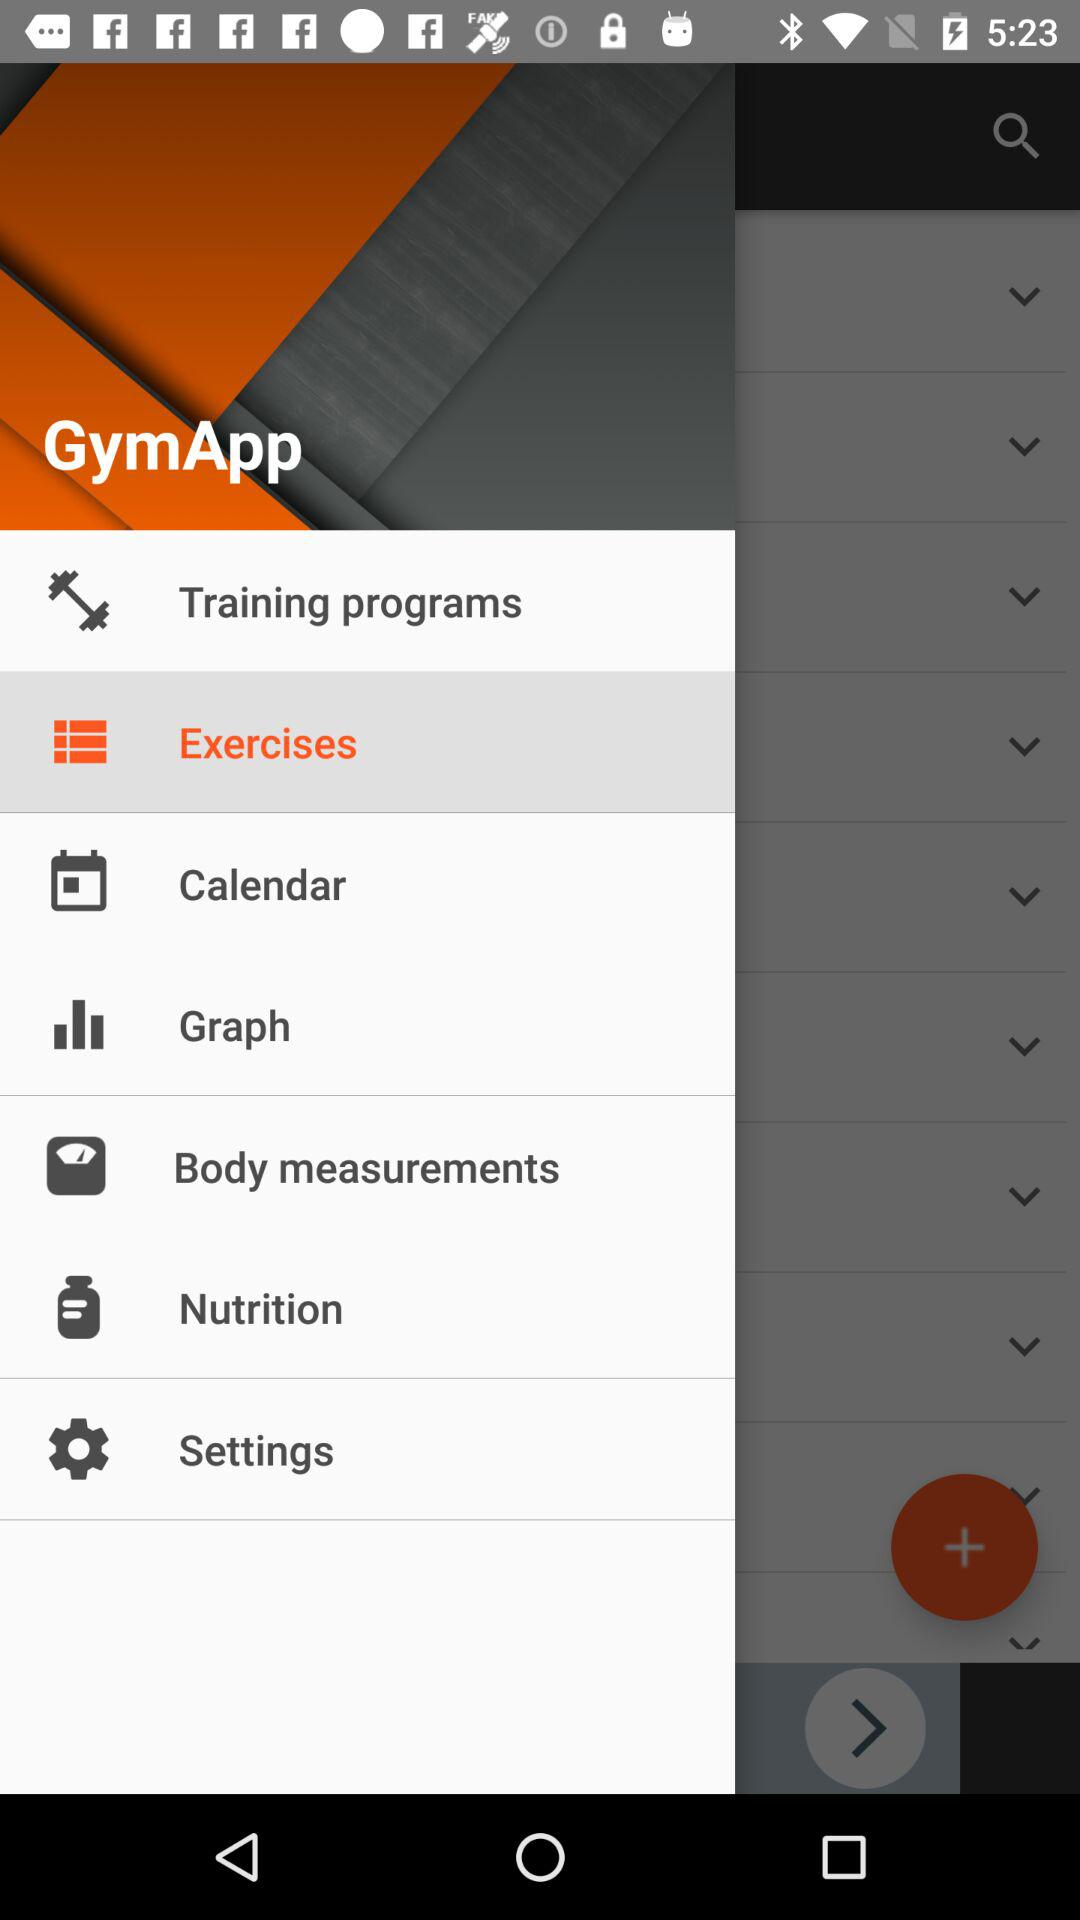What is the name of the application? The name of the application is "GymApp". 